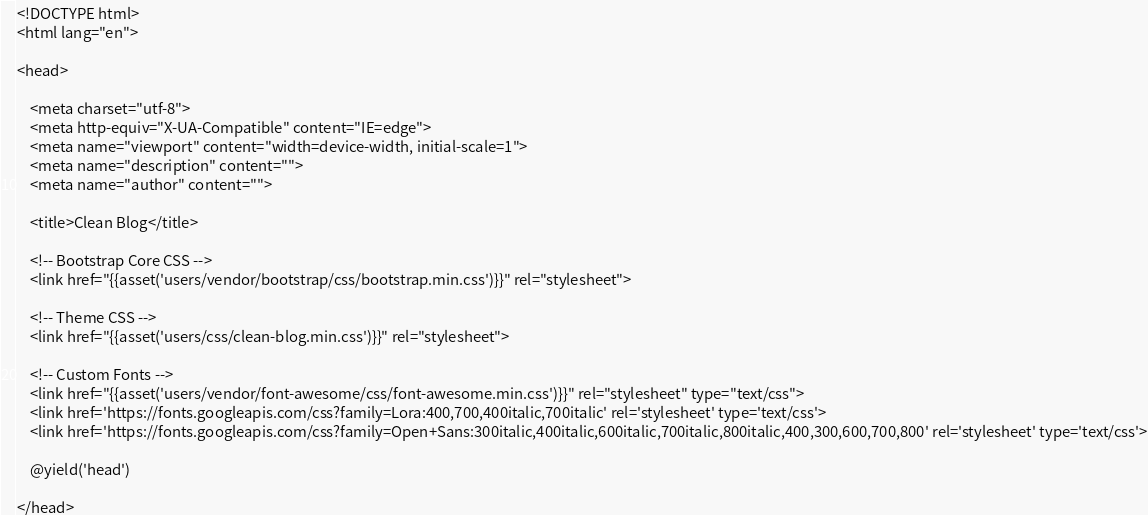Convert code to text. <code><loc_0><loc_0><loc_500><loc_500><_PHP_><!DOCTYPE html>
<html lang="en">

<head>

    <meta charset="utf-8">
    <meta http-equiv="X-UA-Compatible" content="IE=edge">
    <meta name="viewport" content="width=device-width, initial-scale=1">
    <meta name="description" content="">
    <meta name="author" content="">

    <title>Clean Blog</title>

    <!-- Bootstrap Core CSS -->
    <link href="{{asset('users/vendor/bootstrap/css/bootstrap.min.css')}}" rel="stylesheet">

    <!-- Theme CSS -->
    <link href="{{asset('users/css/clean-blog.min.css')}}" rel="stylesheet">

    <!-- Custom Fonts -->
    <link href="{{asset('users/vendor/font-awesome/css/font-awesome.min.css')}}" rel="stylesheet" type="text/css">
    <link href='https://fonts.googleapis.com/css?family=Lora:400,700,400italic,700italic' rel='stylesheet' type='text/css'>
    <link href='https://fonts.googleapis.com/css?family=Open+Sans:300italic,400italic,600italic,700italic,800italic,400,300,600,700,800' rel='stylesheet' type='text/css'>

    @yield('head')

</head></code> 